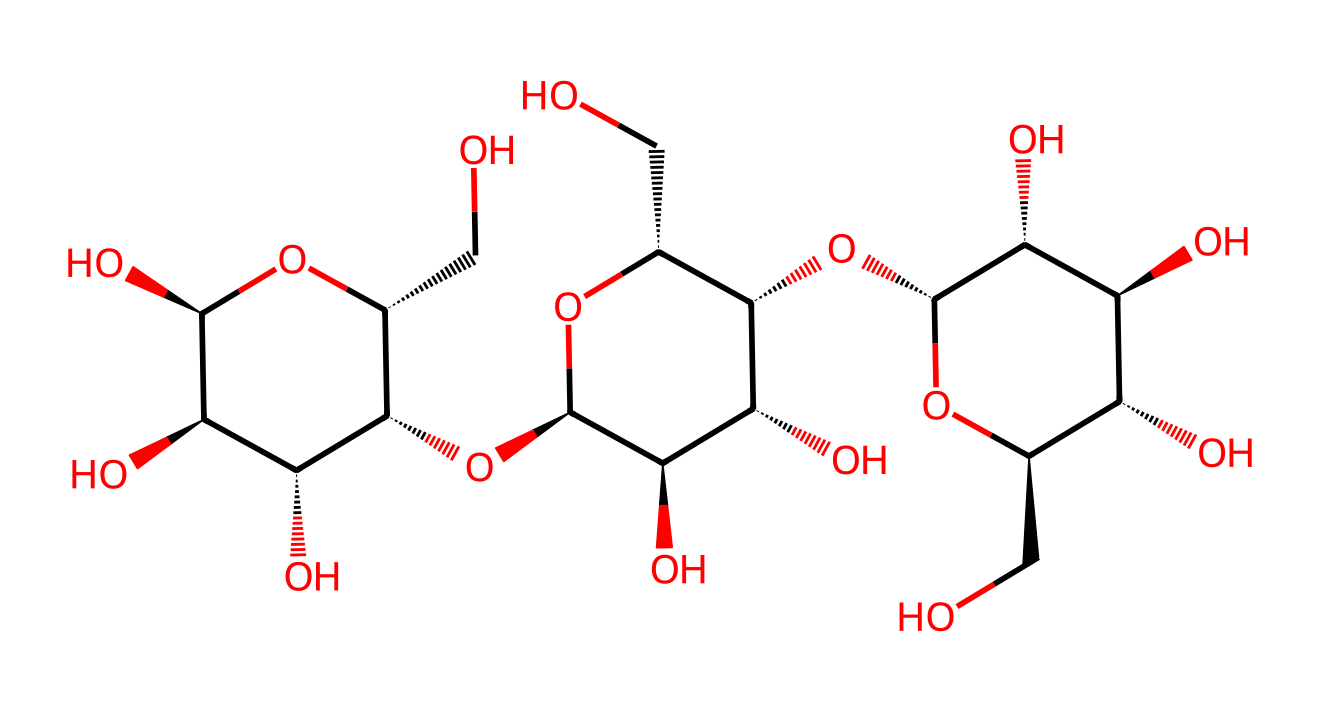How many carbon atoms are present in the molecule? By analyzing the SMILES representation, each carbon atom can be identified from the letter 'C'. Counting the 'C' symbols in the structure gives a total of 6 carbon atoms.
Answer: 6 What type of bonds are present between the carbon atoms in cellulose? In cellulose, the structure formed by the carbon atoms primarily features covalent bonds. These bonds are formed through the sharing of electrons between carbon atoms, indicative of a typical organic compound.
Answer: covalent What is the primary functional group present in this cellulose structure? By examining the SMILES, we can identify multiple -OH (hydroxyl) groups attached to the carbon atoms. This functional group is critical in determining the properties of cellulose.
Answer: hydroxyl What variation of glucose is present in the cellulose structure? The structure is based on the repeating units of glucose, specifically β-D-glucose. This is evident by recognizing the orientation of the hydroxyl groups on the carbons, adhering to the β-anomeric configuration.
Answer: β-D-glucose What property of cellulose allows it to be insoluble in water? The extensive hydrogen bonding between the hydroxyl groups within and between cellulose chains forms a rigid structure, limiting the ability of water to penetrate and dissolve cellulose fibers.
Answer: hydrogen bonding What type of polymer is cellulose classified as? Cellulose is classified as a homopolymer because it consists solely of repeated units of a single type of monomer, which in this case is the β-D-glucose unit.
Answer: homopolymer What is the degree of polymerization of cellulose? The degree of polymerization can be inferred from the intrinsic long-chain structure of cellulose, which typically consists of thousands of glucose units bonded together, indicating a high polymerization value.
Answer: high 